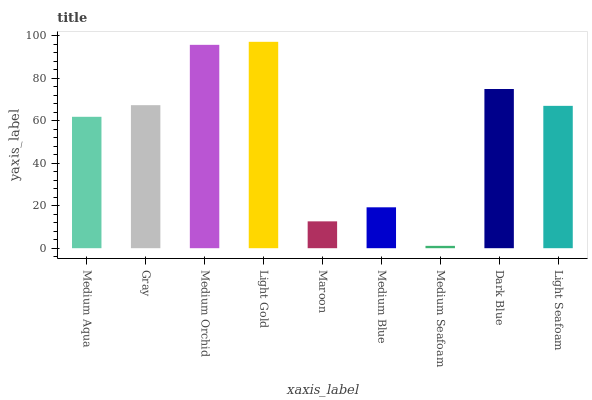Is Medium Seafoam the minimum?
Answer yes or no. Yes. Is Light Gold the maximum?
Answer yes or no. Yes. Is Gray the minimum?
Answer yes or no. No. Is Gray the maximum?
Answer yes or no. No. Is Gray greater than Medium Aqua?
Answer yes or no. Yes. Is Medium Aqua less than Gray?
Answer yes or no. Yes. Is Medium Aqua greater than Gray?
Answer yes or no. No. Is Gray less than Medium Aqua?
Answer yes or no. No. Is Light Seafoam the high median?
Answer yes or no. Yes. Is Light Seafoam the low median?
Answer yes or no. Yes. Is Medium Seafoam the high median?
Answer yes or no. No. Is Medium Aqua the low median?
Answer yes or no. No. 